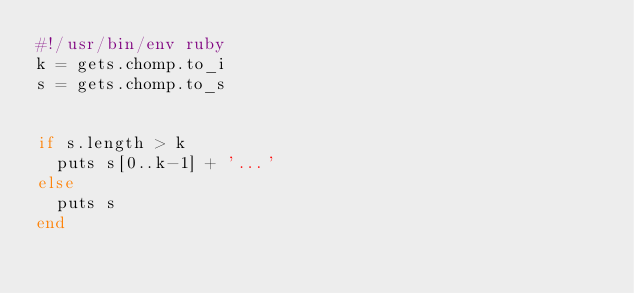Convert code to text. <code><loc_0><loc_0><loc_500><loc_500><_Ruby_>#!/usr/bin/env ruby
k = gets.chomp.to_i
s = gets.chomp.to_s


if s.length > k
  puts s[0..k-1] + '...'
else
  puts s
end
</code> 